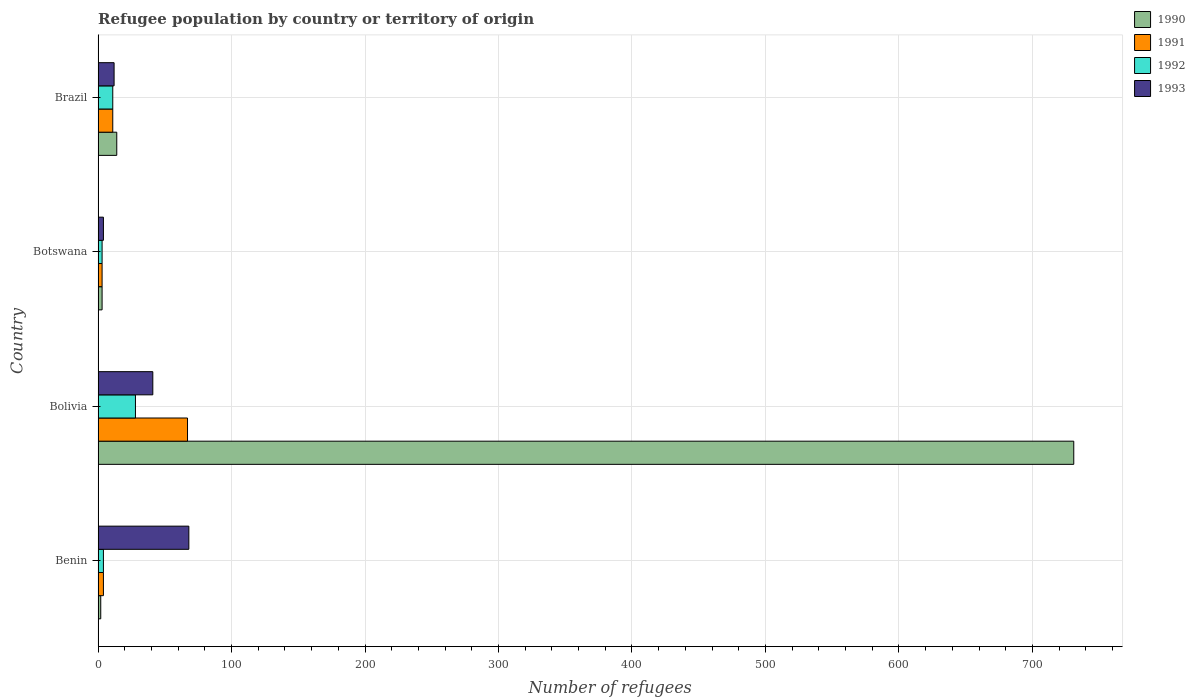How many different coloured bars are there?
Provide a short and direct response. 4. How many groups of bars are there?
Offer a very short reply. 4. How many bars are there on the 4th tick from the bottom?
Ensure brevity in your answer.  4. In how many cases, is the number of bars for a given country not equal to the number of legend labels?
Provide a short and direct response. 0. What is the number of refugees in 1990 in Bolivia?
Your response must be concise. 731. Across all countries, what is the maximum number of refugees in 1990?
Your response must be concise. 731. Across all countries, what is the minimum number of refugees in 1993?
Your answer should be very brief. 4. In which country was the number of refugees in 1990 minimum?
Provide a short and direct response. Benin. What is the total number of refugees in 1993 in the graph?
Keep it short and to the point. 125. What is the difference between the number of refugees in 1992 in Bolivia and that in Brazil?
Your response must be concise. 17. What is the difference between the number of refugees in 1992 in Botswana and the number of refugees in 1990 in Bolivia?
Your answer should be compact. -728. What is the average number of refugees in 1991 per country?
Offer a very short reply. 21.25. In how many countries, is the number of refugees in 1990 greater than 40 ?
Offer a very short reply. 1. What is the ratio of the number of refugees in 1992 in Benin to that in Botswana?
Keep it short and to the point. 1.33. Is the difference between the number of refugees in 1990 in Benin and Brazil greater than the difference between the number of refugees in 1993 in Benin and Brazil?
Offer a very short reply. No. Is the sum of the number of refugees in 1992 in Bolivia and Botswana greater than the maximum number of refugees in 1990 across all countries?
Make the answer very short. No. Is it the case that in every country, the sum of the number of refugees in 1991 and number of refugees in 1990 is greater than the sum of number of refugees in 1993 and number of refugees in 1992?
Ensure brevity in your answer.  No. Are the values on the major ticks of X-axis written in scientific E-notation?
Offer a terse response. No. How many legend labels are there?
Your response must be concise. 4. How are the legend labels stacked?
Ensure brevity in your answer.  Vertical. What is the title of the graph?
Ensure brevity in your answer.  Refugee population by country or territory of origin. What is the label or title of the X-axis?
Offer a very short reply. Number of refugees. What is the label or title of the Y-axis?
Ensure brevity in your answer.  Country. What is the Number of refugees of 1990 in Benin?
Provide a short and direct response. 2. What is the Number of refugees of 1991 in Benin?
Give a very brief answer. 4. What is the Number of refugees of 1992 in Benin?
Offer a very short reply. 4. What is the Number of refugees of 1990 in Bolivia?
Keep it short and to the point. 731. What is the Number of refugees in 1993 in Bolivia?
Your answer should be compact. 41. What is the Number of refugees of 1990 in Botswana?
Offer a very short reply. 3. What is the Number of refugees in 1993 in Botswana?
Give a very brief answer. 4. What is the Number of refugees in 1992 in Brazil?
Offer a very short reply. 11. What is the Number of refugees in 1993 in Brazil?
Your answer should be very brief. 12. Across all countries, what is the maximum Number of refugees of 1990?
Offer a very short reply. 731. Across all countries, what is the maximum Number of refugees in 1991?
Provide a short and direct response. 67. Across all countries, what is the maximum Number of refugees of 1993?
Keep it short and to the point. 68. Across all countries, what is the minimum Number of refugees of 1991?
Your answer should be compact. 3. Across all countries, what is the minimum Number of refugees in 1992?
Keep it short and to the point. 3. Across all countries, what is the minimum Number of refugees in 1993?
Provide a short and direct response. 4. What is the total Number of refugees of 1990 in the graph?
Provide a succinct answer. 750. What is the total Number of refugees of 1993 in the graph?
Offer a very short reply. 125. What is the difference between the Number of refugees in 1990 in Benin and that in Bolivia?
Make the answer very short. -729. What is the difference between the Number of refugees in 1991 in Benin and that in Bolivia?
Provide a short and direct response. -63. What is the difference between the Number of refugees in 1991 in Benin and that in Botswana?
Your response must be concise. 1. What is the difference between the Number of refugees of 1992 in Benin and that in Botswana?
Keep it short and to the point. 1. What is the difference between the Number of refugees in 1993 in Benin and that in Botswana?
Make the answer very short. 64. What is the difference between the Number of refugees in 1990 in Benin and that in Brazil?
Your answer should be compact. -12. What is the difference between the Number of refugees in 1992 in Benin and that in Brazil?
Keep it short and to the point. -7. What is the difference between the Number of refugees of 1990 in Bolivia and that in Botswana?
Offer a very short reply. 728. What is the difference between the Number of refugees of 1990 in Bolivia and that in Brazil?
Offer a very short reply. 717. What is the difference between the Number of refugees in 1992 in Bolivia and that in Brazil?
Ensure brevity in your answer.  17. What is the difference between the Number of refugees in 1993 in Bolivia and that in Brazil?
Ensure brevity in your answer.  29. What is the difference between the Number of refugees in 1990 in Botswana and that in Brazil?
Your answer should be very brief. -11. What is the difference between the Number of refugees in 1991 in Botswana and that in Brazil?
Ensure brevity in your answer.  -8. What is the difference between the Number of refugees of 1992 in Botswana and that in Brazil?
Provide a succinct answer. -8. What is the difference between the Number of refugees in 1990 in Benin and the Number of refugees in 1991 in Bolivia?
Give a very brief answer. -65. What is the difference between the Number of refugees of 1990 in Benin and the Number of refugees of 1993 in Bolivia?
Keep it short and to the point. -39. What is the difference between the Number of refugees in 1991 in Benin and the Number of refugees in 1992 in Bolivia?
Your answer should be compact. -24. What is the difference between the Number of refugees in 1991 in Benin and the Number of refugees in 1993 in Bolivia?
Provide a succinct answer. -37. What is the difference between the Number of refugees in 1992 in Benin and the Number of refugees in 1993 in Bolivia?
Offer a terse response. -37. What is the difference between the Number of refugees of 1990 in Benin and the Number of refugees of 1993 in Botswana?
Offer a very short reply. -2. What is the difference between the Number of refugees in 1991 in Benin and the Number of refugees in 1992 in Botswana?
Provide a succinct answer. 1. What is the difference between the Number of refugees of 1991 in Benin and the Number of refugees of 1993 in Botswana?
Provide a succinct answer. 0. What is the difference between the Number of refugees in 1992 in Benin and the Number of refugees in 1993 in Botswana?
Offer a terse response. 0. What is the difference between the Number of refugees in 1990 in Benin and the Number of refugees in 1991 in Brazil?
Make the answer very short. -9. What is the difference between the Number of refugees of 1990 in Benin and the Number of refugees of 1993 in Brazil?
Keep it short and to the point. -10. What is the difference between the Number of refugees in 1991 in Benin and the Number of refugees in 1992 in Brazil?
Keep it short and to the point. -7. What is the difference between the Number of refugees in 1991 in Benin and the Number of refugees in 1993 in Brazil?
Your answer should be very brief. -8. What is the difference between the Number of refugees in 1992 in Benin and the Number of refugees in 1993 in Brazil?
Offer a terse response. -8. What is the difference between the Number of refugees of 1990 in Bolivia and the Number of refugees of 1991 in Botswana?
Provide a succinct answer. 728. What is the difference between the Number of refugees in 1990 in Bolivia and the Number of refugees in 1992 in Botswana?
Keep it short and to the point. 728. What is the difference between the Number of refugees of 1990 in Bolivia and the Number of refugees of 1993 in Botswana?
Your response must be concise. 727. What is the difference between the Number of refugees of 1991 in Bolivia and the Number of refugees of 1992 in Botswana?
Ensure brevity in your answer.  64. What is the difference between the Number of refugees of 1992 in Bolivia and the Number of refugees of 1993 in Botswana?
Provide a succinct answer. 24. What is the difference between the Number of refugees in 1990 in Bolivia and the Number of refugees in 1991 in Brazil?
Provide a succinct answer. 720. What is the difference between the Number of refugees in 1990 in Bolivia and the Number of refugees in 1992 in Brazil?
Offer a terse response. 720. What is the difference between the Number of refugees in 1990 in Bolivia and the Number of refugees in 1993 in Brazil?
Your answer should be compact. 719. What is the difference between the Number of refugees in 1991 in Bolivia and the Number of refugees in 1992 in Brazil?
Provide a short and direct response. 56. What is the difference between the Number of refugees of 1992 in Bolivia and the Number of refugees of 1993 in Brazil?
Your answer should be very brief. 16. What is the difference between the Number of refugees in 1990 in Botswana and the Number of refugees in 1992 in Brazil?
Keep it short and to the point. -8. What is the difference between the Number of refugees of 1990 in Botswana and the Number of refugees of 1993 in Brazil?
Make the answer very short. -9. What is the difference between the Number of refugees of 1991 in Botswana and the Number of refugees of 1992 in Brazil?
Your answer should be compact. -8. What is the average Number of refugees in 1990 per country?
Your answer should be very brief. 187.5. What is the average Number of refugees of 1991 per country?
Offer a very short reply. 21.25. What is the average Number of refugees in 1993 per country?
Give a very brief answer. 31.25. What is the difference between the Number of refugees in 1990 and Number of refugees in 1991 in Benin?
Ensure brevity in your answer.  -2. What is the difference between the Number of refugees of 1990 and Number of refugees of 1993 in Benin?
Provide a succinct answer. -66. What is the difference between the Number of refugees in 1991 and Number of refugees in 1993 in Benin?
Offer a terse response. -64. What is the difference between the Number of refugees in 1992 and Number of refugees in 1993 in Benin?
Your response must be concise. -64. What is the difference between the Number of refugees of 1990 and Number of refugees of 1991 in Bolivia?
Provide a succinct answer. 664. What is the difference between the Number of refugees in 1990 and Number of refugees in 1992 in Bolivia?
Your answer should be very brief. 703. What is the difference between the Number of refugees of 1990 and Number of refugees of 1993 in Bolivia?
Provide a succinct answer. 690. What is the difference between the Number of refugees of 1991 and Number of refugees of 1992 in Bolivia?
Ensure brevity in your answer.  39. What is the difference between the Number of refugees in 1992 and Number of refugees in 1993 in Bolivia?
Make the answer very short. -13. What is the difference between the Number of refugees in 1990 and Number of refugees in 1991 in Botswana?
Your response must be concise. 0. What is the difference between the Number of refugees of 1990 and Number of refugees of 1993 in Botswana?
Offer a terse response. -1. What is the difference between the Number of refugees in 1991 and Number of refugees in 1993 in Botswana?
Make the answer very short. -1. What is the difference between the Number of refugees in 1992 and Number of refugees in 1993 in Botswana?
Provide a succinct answer. -1. What is the difference between the Number of refugees of 1990 and Number of refugees of 1991 in Brazil?
Give a very brief answer. 3. What is the ratio of the Number of refugees in 1990 in Benin to that in Bolivia?
Provide a succinct answer. 0. What is the ratio of the Number of refugees in 1991 in Benin to that in Bolivia?
Ensure brevity in your answer.  0.06. What is the ratio of the Number of refugees in 1992 in Benin to that in Bolivia?
Provide a short and direct response. 0.14. What is the ratio of the Number of refugees of 1993 in Benin to that in Bolivia?
Provide a short and direct response. 1.66. What is the ratio of the Number of refugees in 1990 in Benin to that in Brazil?
Ensure brevity in your answer.  0.14. What is the ratio of the Number of refugees in 1991 in Benin to that in Brazil?
Your answer should be compact. 0.36. What is the ratio of the Number of refugees of 1992 in Benin to that in Brazil?
Your answer should be compact. 0.36. What is the ratio of the Number of refugees in 1993 in Benin to that in Brazil?
Keep it short and to the point. 5.67. What is the ratio of the Number of refugees of 1990 in Bolivia to that in Botswana?
Make the answer very short. 243.67. What is the ratio of the Number of refugees in 1991 in Bolivia to that in Botswana?
Provide a short and direct response. 22.33. What is the ratio of the Number of refugees of 1992 in Bolivia to that in Botswana?
Your answer should be compact. 9.33. What is the ratio of the Number of refugees in 1993 in Bolivia to that in Botswana?
Your response must be concise. 10.25. What is the ratio of the Number of refugees of 1990 in Bolivia to that in Brazil?
Offer a terse response. 52.21. What is the ratio of the Number of refugees of 1991 in Bolivia to that in Brazil?
Keep it short and to the point. 6.09. What is the ratio of the Number of refugees in 1992 in Bolivia to that in Brazil?
Offer a very short reply. 2.55. What is the ratio of the Number of refugees of 1993 in Bolivia to that in Brazil?
Give a very brief answer. 3.42. What is the ratio of the Number of refugees in 1990 in Botswana to that in Brazil?
Provide a succinct answer. 0.21. What is the ratio of the Number of refugees in 1991 in Botswana to that in Brazil?
Provide a succinct answer. 0.27. What is the ratio of the Number of refugees of 1992 in Botswana to that in Brazil?
Give a very brief answer. 0.27. What is the ratio of the Number of refugees of 1993 in Botswana to that in Brazil?
Provide a succinct answer. 0.33. What is the difference between the highest and the second highest Number of refugees in 1990?
Your response must be concise. 717. What is the difference between the highest and the second highest Number of refugees of 1991?
Ensure brevity in your answer.  56. What is the difference between the highest and the lowest Number of refugees in 1990?
Offer a terse response. 729. 